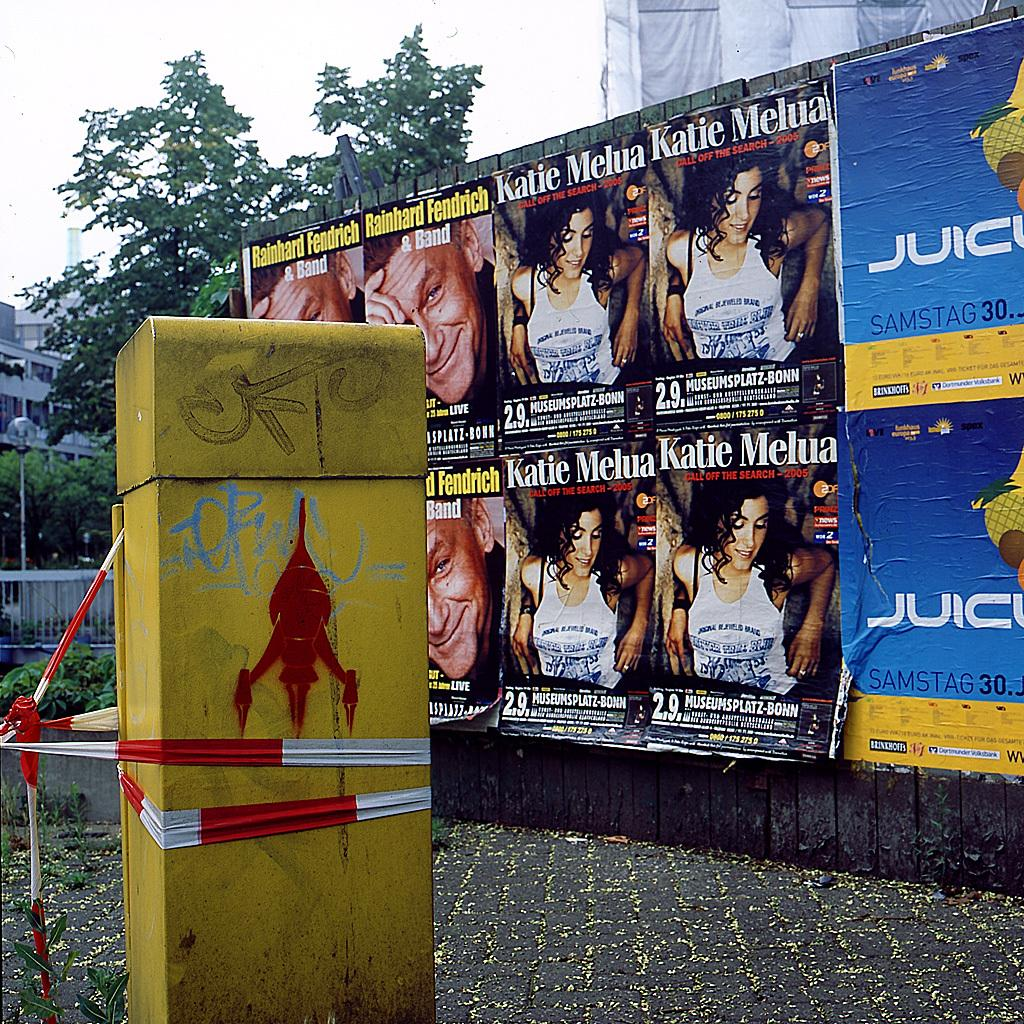<image>
Give a short and clear explanation of the subsequent image. Posters for Katue Melua hang on a wall outside. 